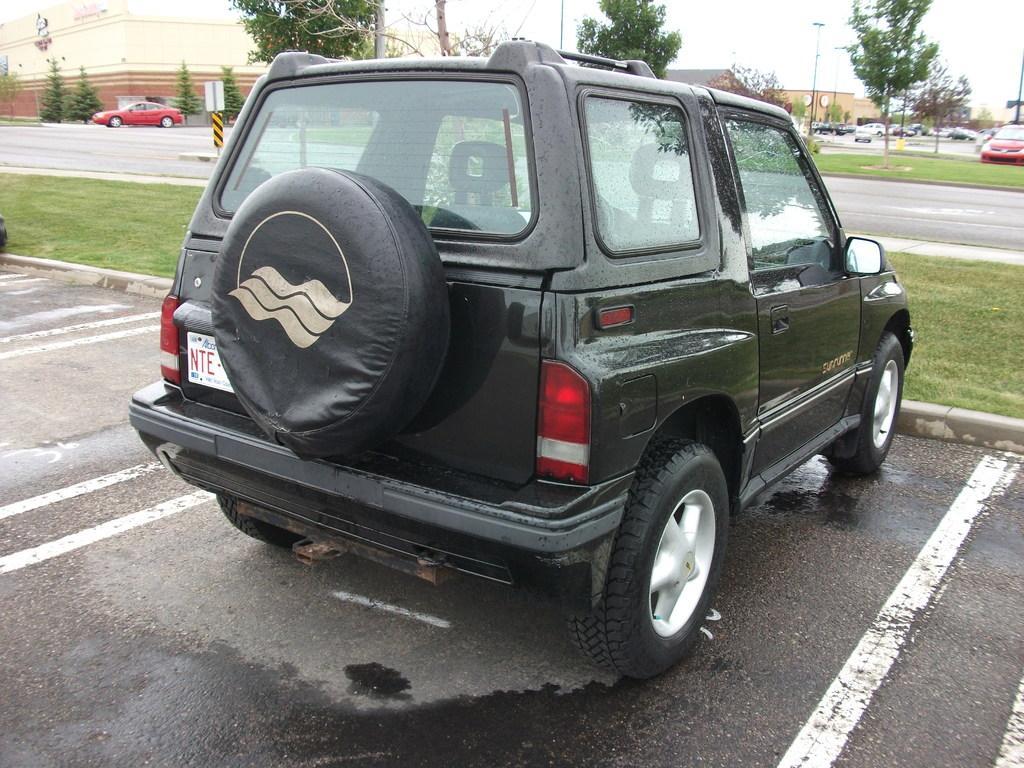Describe this image in one or two sentences. In this image there are roads, on that road there are vehicles, in the background there are tree and houses. 